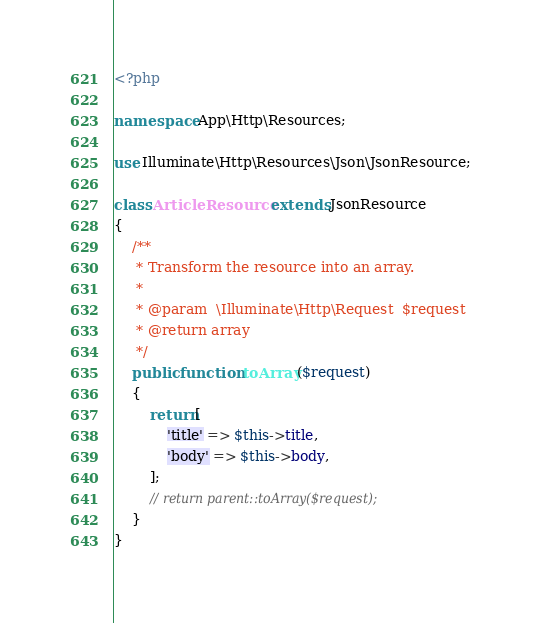Convert code to text. <code><loc_0><loc_0><loc_500><loc_500><_PHP_><?php

namespace App\Http\Resources;

use Illuminate\Http\Resources\Json\JsonResource;

class ArticleResource extends JsonResource
{
    /**
     * Transform the resource into an array.
     *
     * @param  \Illuminate\Http\Request  $request
     * @return array
     */
    public function toArray($request)
    {
        return[
            'title' => $this->title,
            'body' => $this->body,
        ];
        // return parent::toArray($request);
    }
}
</code> 